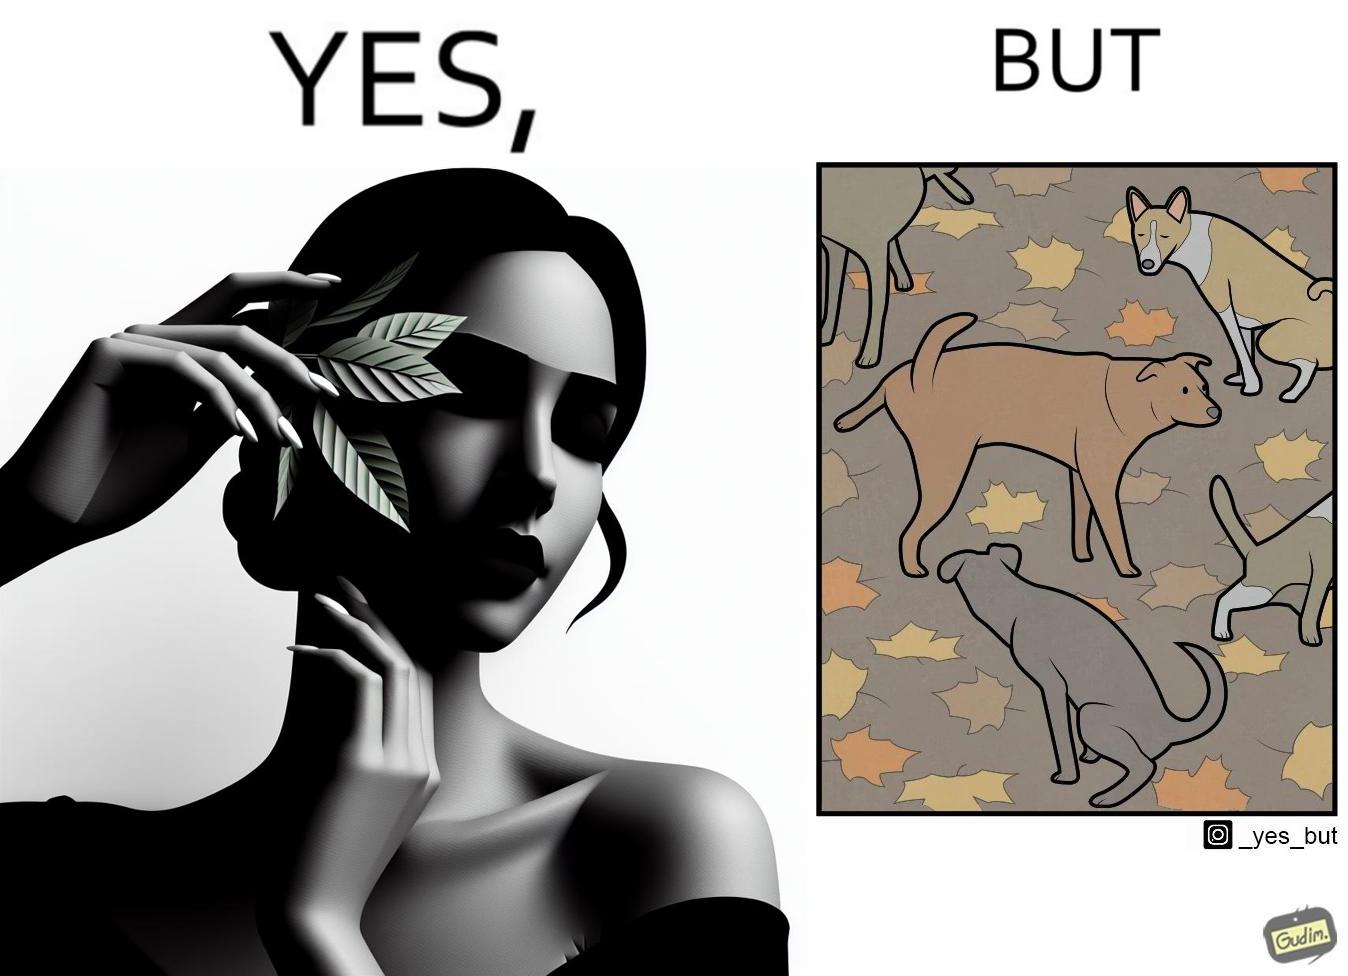What makes this image funny or satirical? The images are funny since it show a woman holding a leaf over half of her face for a good photo but unknown to her is thale fact the same leaf might have been defecated or urinated upon by dogs and other wild animals 